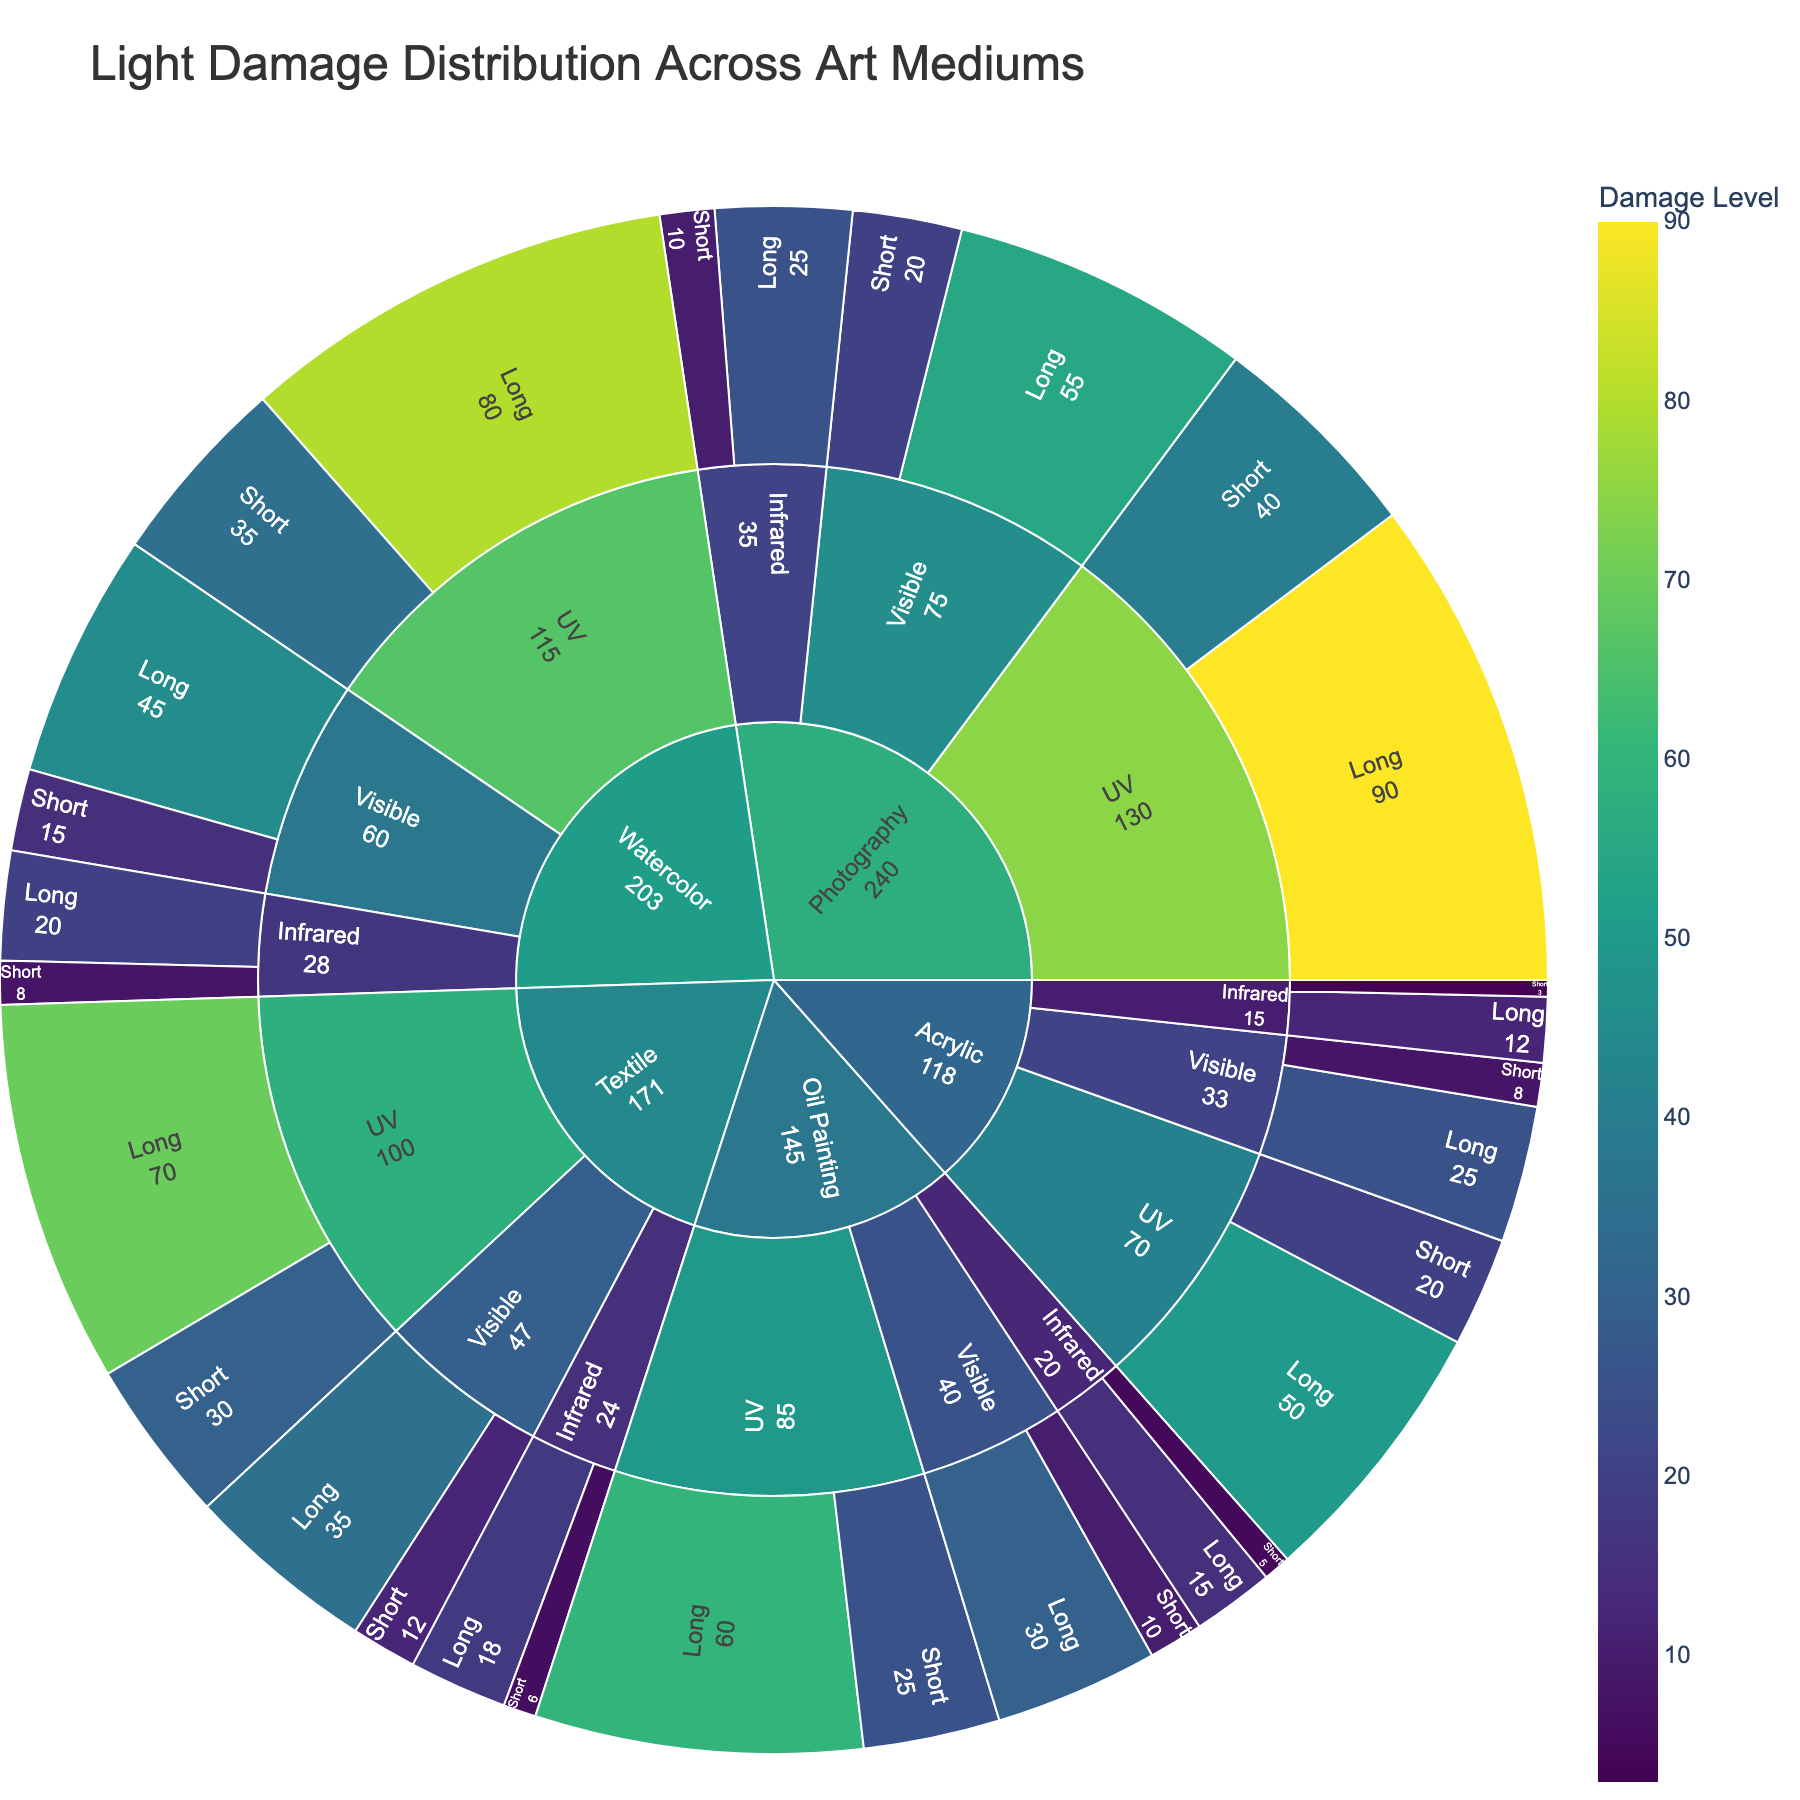what is the title of the figure? The title of the figure is displayed at the top and it summarizes what the figure represents. The title is "Light Damage Distribution Across Art Mediums".
Answer: Light Damage Distribution Across Art Mediums For which medium and wavelength is the damage level highest during long exposure? To determine this, look for the outermost ring segment with the highest value, specifically under the 'Long' exposure time category. For long UV exposure, Photography has the highest damage level of 90.
Answer: Photography, UV Which art medium exhibits the lowest damage level under short exposure to infrared light? By examining the outer ring segments corresponding to 'Short' exposure under 'Infrared' light, Acrylic has the lowest damage level of 3.
Answer: Acrylic What is the damage level for Watercolor under long exposure to visible light? Navigate to the segment labeled 'Watercolor', then to the 'Visible' wavelength, and finally to 'Long' exposure. The damage level here is 45.
Answer: 45 Between Oil Painting and Watercolor, which medium suffers more damage under long exposure to UV light? Compare the damage levels for Oil Painting and Watercolor under 'Long' exposure to 'UV' light. Oil Painting has a level of 60, whereas Watercolor has a level of 80, so Watercolor suffers more damage.
Answer: Watercolor What is the overall damage level difference between short and long UV exposure for Acrylic? Find the damage levels for Acrylic under 'Short' UV exposure (20) and 'Long' UV exposure (50). Subtract the short exposure damage level from the long exposure damage level: 50 - 20 = 30.
Answer: 30 Which medium has the highest damage from long exposure to visible light? Check the segments labeled 'Long' under 'Visible' light for each medium. Photography has the highest damage level of 55.
Answer: Photography Comparing Textile and Photography, which medium has more damage from short exposure to visible light, and by how much? Textile has a damage level of 12, and Photography has 20 under 'Short' exposure to 'Visible' light. The difference is 20 - 12 = 8.
Answer: Photography, 8 Is the damage level higher for Watercolor under short infrared or short visible exposure? Compare the segments for Watercolor under 'Short' exposure to 'Infrared' (8) and 'Visible' (15). The damage level is higher under 'Visible' light.
Answer: Short Visible How many art mediums were analyzed in the figure? The figure has an inner ring representing different art mediums. Count the unique labels: Oil Painting, Watercolor, Acrylic, Textile, and Photography. There are 5 mediums.
Answer: 5 